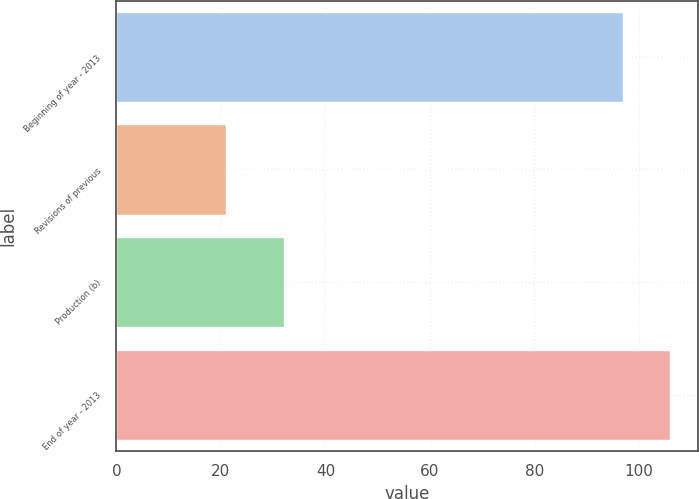<chart> <loc_0><loc_0><loc_500><loc_500><bar_chart><fcel>Beginning of year - 2013<fcel>Revisions of previous<fcel>Production (b)<fcel>End of year - 2013<nl><fcel>97<fcel>21<fcel>32<fcel>106<nl></chart> 